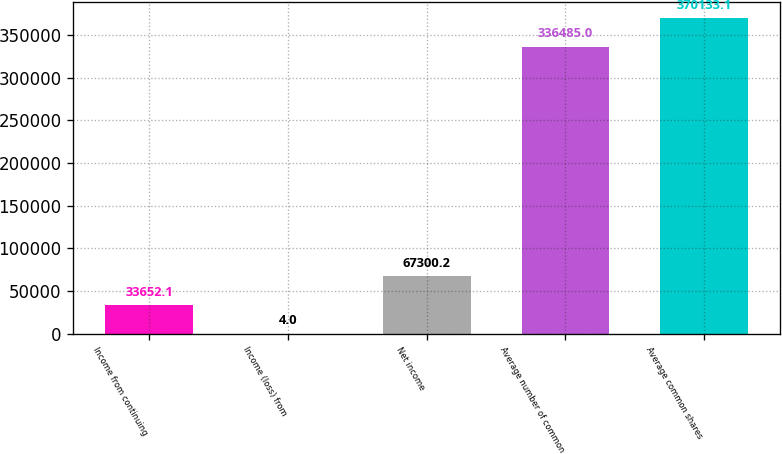Convert chart to OTSL. <chart><loc_0><loc_0><loc_500><loc_500><bar_chart><fcel>Income from continuing<fcel>Income (loss) from<fcel>Net income<fcel>Average number of common<fcel>Average common shares<nl><fcel>33652.1<fcel>4<fcel>67300.2<fcel>336485<fcel>370133<nl></chart> 